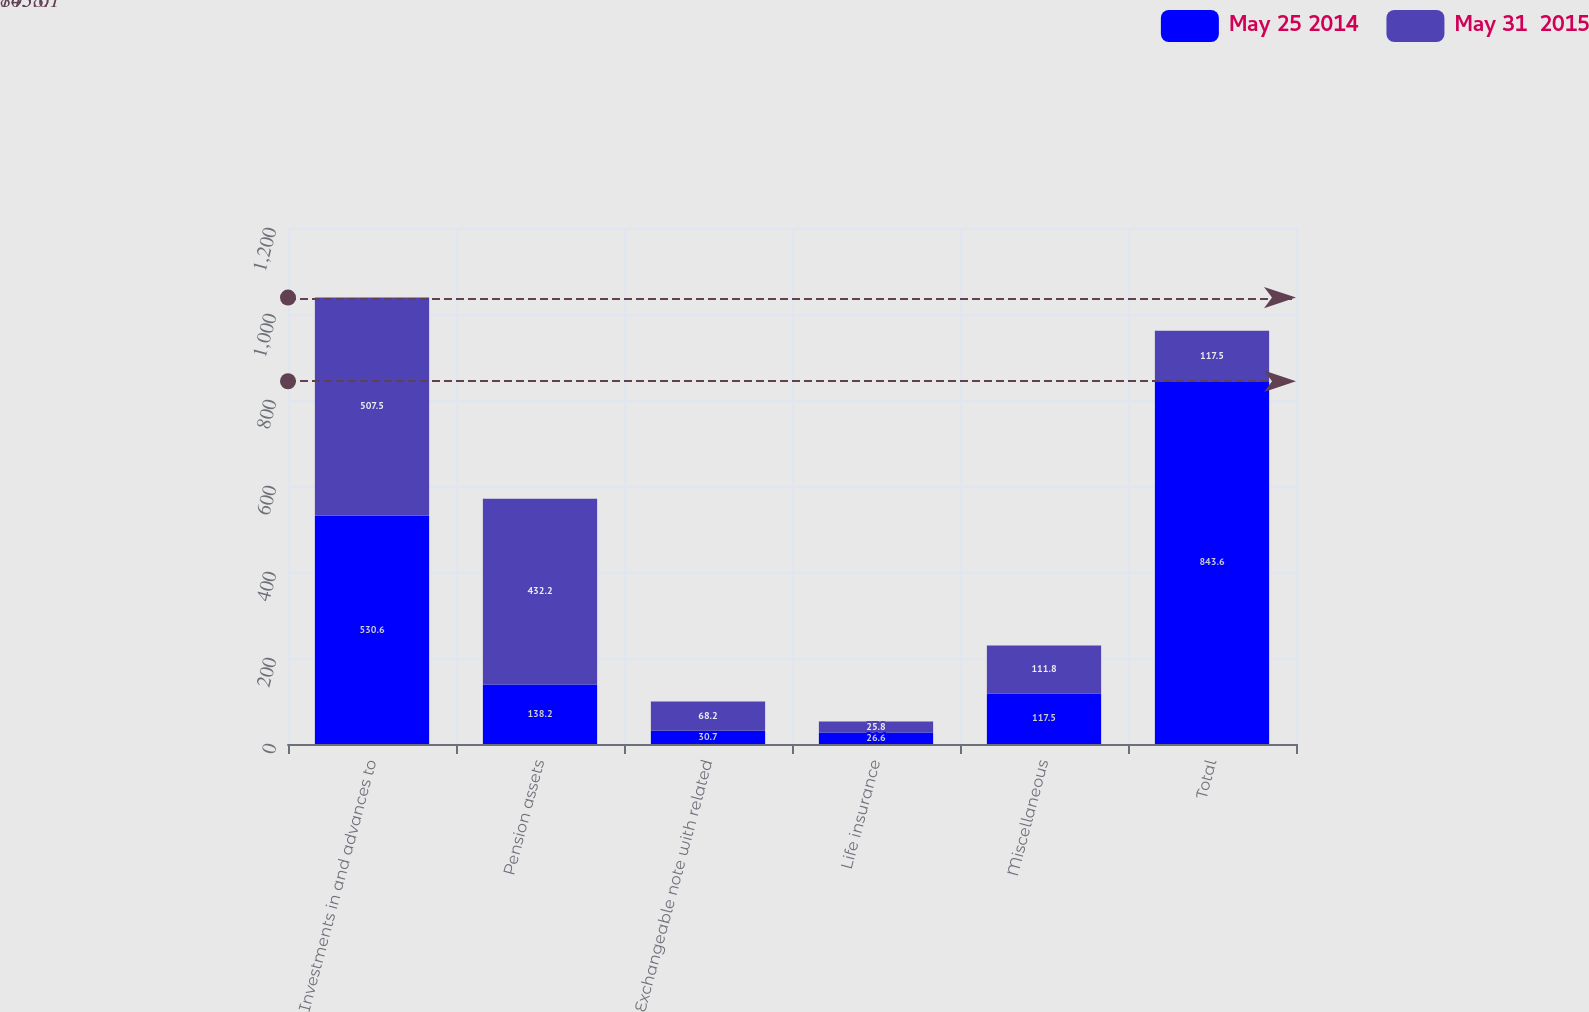<chart> <loc_0><loc_0><loc_500><loc_500><stacked_bar_chart><ecel><fcel>Investments in and advances to<fcel>Pension assets<fcel>Exchangeable note with related<fcel>Life insurance<fcel>Miscellaneous<fcel>Total<nl><fcel>May 25 2014<fcel>530.6<fcel>138.2<fcel>30.7<fcel>26.6<fcel>117.5<fcel>843.6<nl><fcel>May 31  2015<fcel>507.5<fcel>432.2<fcel>68.2<fcel>25.8<fcel>111.8<fcel>117.5<nl></chart> 